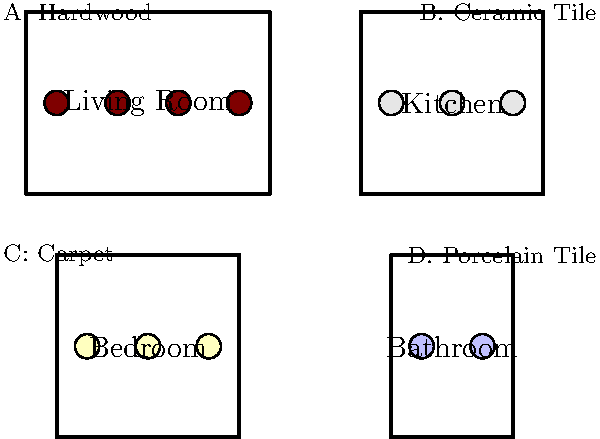Based on the floor plan and material swatches shown, which combination of flooring materials would be most appropriate for the different rooms, considering both function and aesthetics? To determine the most appropriate flooring materials for each room, we need to consider both functionality and aesthetics:

1. Living Room:
   - Requires durability for high traffic
   - Should have a warm, inviting appearance
   - Hardwood (A) is ideal for its classic look and durability

2. Kitchen:
   - Needs water-resistant and easy-to-clean flooring
   - Should be able to withstand spills and heavy use
   - Ceramic tile (B) is perfect for its water resistance and easy maintenance

3. Bedroom:
   - Prioritizes comfort and warmth
   - Should provide a cozy feel underfoot
   - Carpet (C) offers softness and warmth, ideal for bedrooms

4. Bathroom:
   - Requires water-resistant and slip-resistant flooring
   - Must be able to handle high moisture levels
   - Porcelain tile (D) is excellent for its water resistance and durability in wet environments

The combination that best suits each room's function and aesthetics is:
Living Room: A (Hardwood)
Kitchen: B (Ceramic Tile)
Bedroom: C (Carpet)
Bathroom: D (Porcelain Tile)
Answer: A-B-C-D 